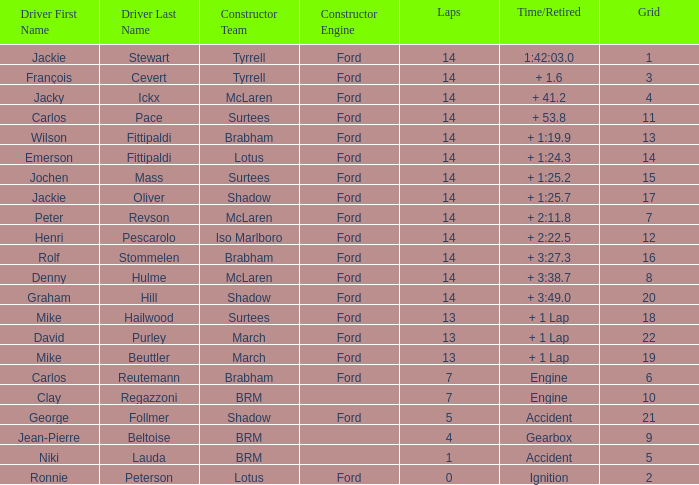What grad has a Time/Retired of + 1:24.3? 14.0. 